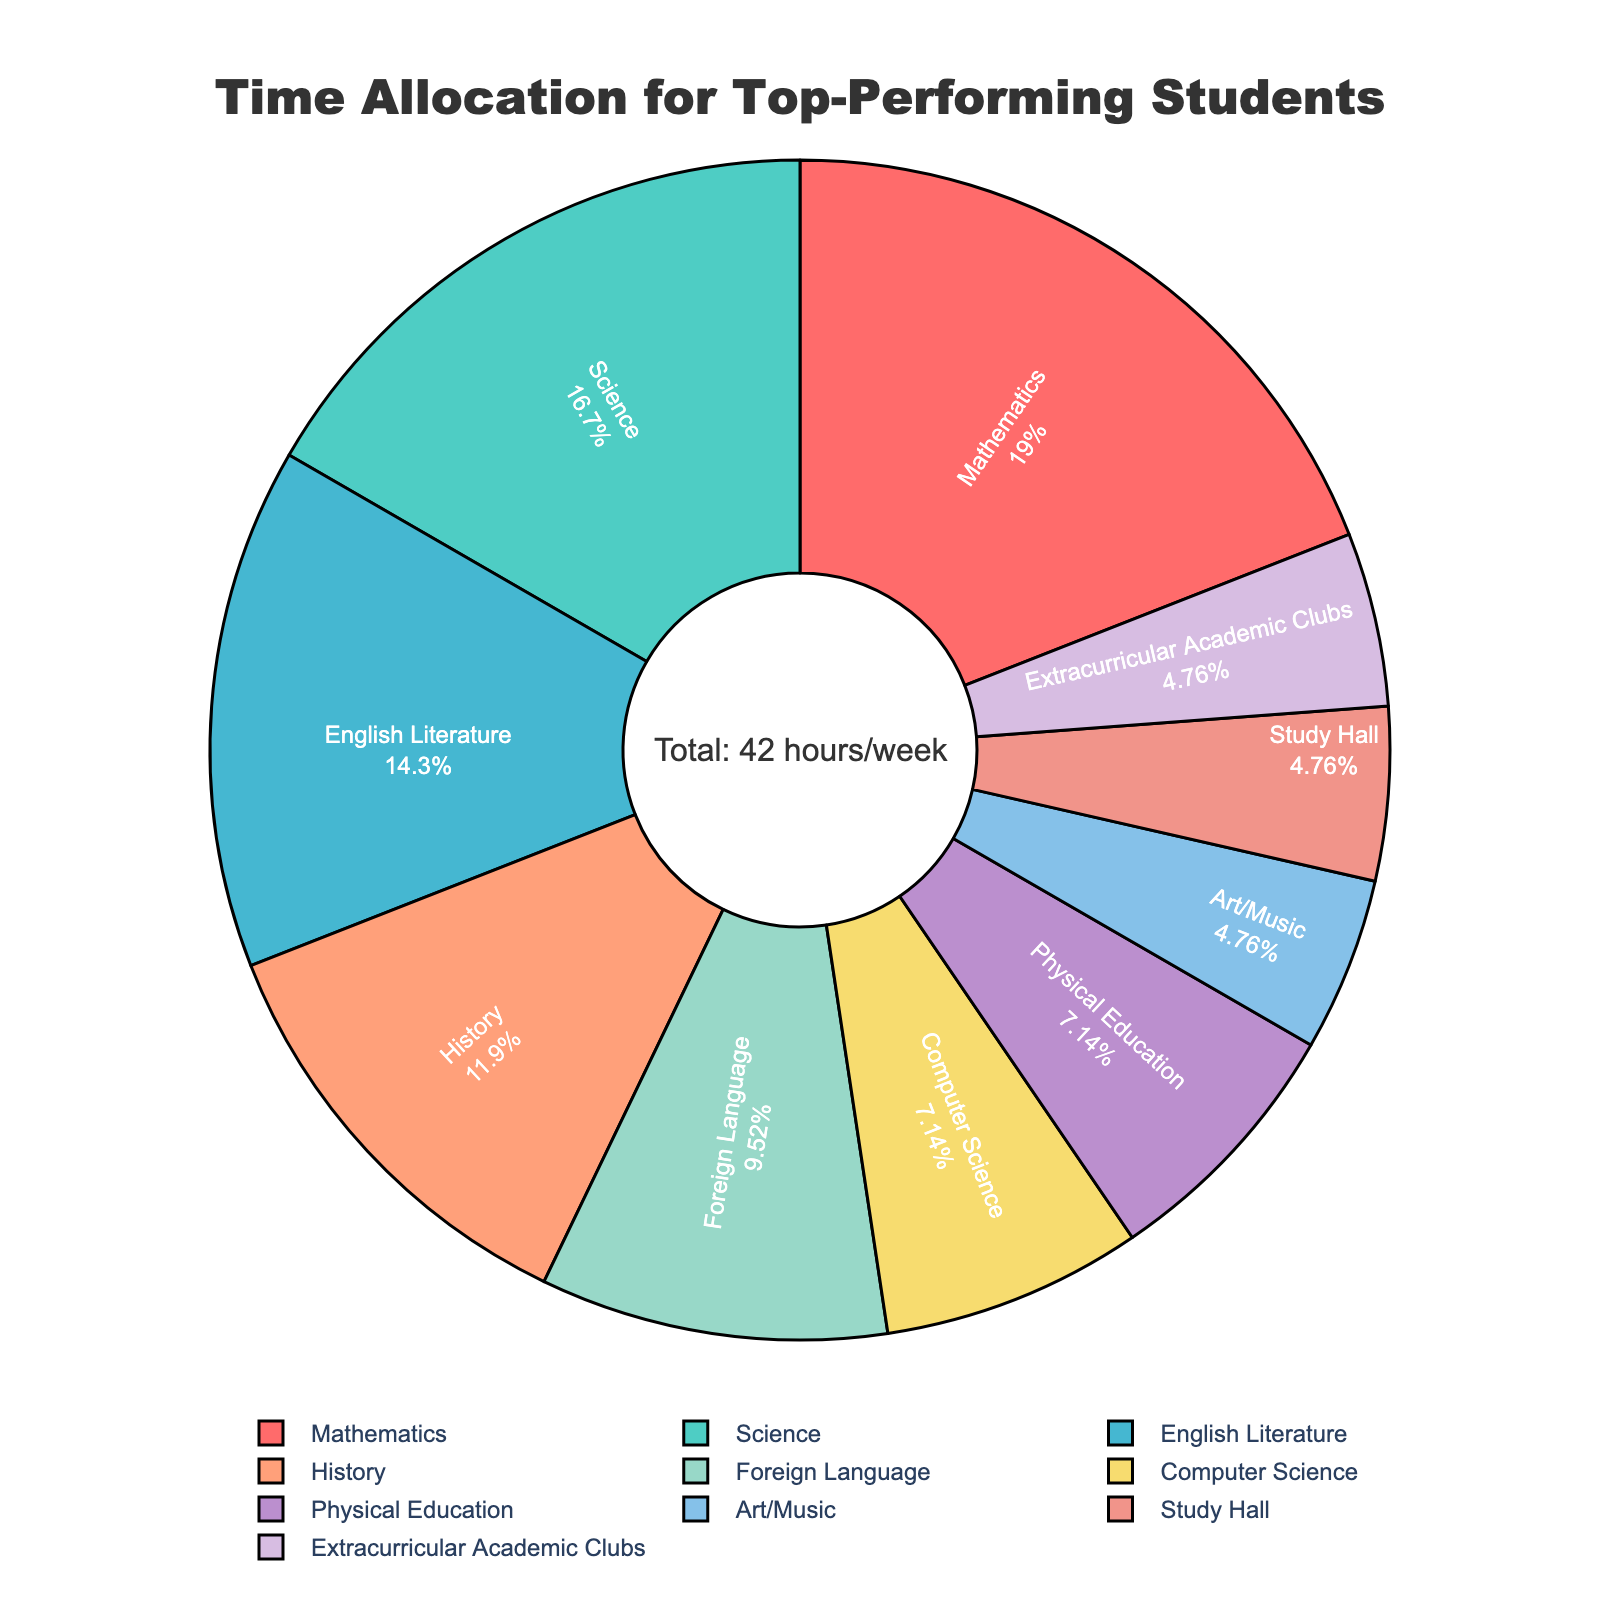What is the subject in which students spend the most time? In the figure, the largest section of the pie chart indicates the subject where students spend the most time. The label for this section will show the subject and its corresponding percentage.
Answer: Mathematics Which two subjects combined take up the same amount of time as Science? Science takes up 7 hours per week. We need to find two subjects whose hours per week sum up to 7. Checking the data, Physical Education and Computer Science each take 3 hours, and Art/Music takes 2 hours. The sum of Physical Education and Art/Music is therefore 3 + 4 = 7, which matches Science.
Answer: Physical Education and Computer Science + Art/Music What percentage of time is spent on Mathematics? The percentage is directly shown in the figure next to the "Mathematics" label.
Answer: 19% Is more time spent on English Literature or History? By comparing the sizes of the sections for "English Literature" and "History" in the pie chart, and referencing their corresponding percentages or hours, it's evident.
Answer: English Literature How does the time spent on Extracurricular Academic Clubs compare to Art/Music? Both sections of the pie chart must be compared. Checking the figure, Extracurricular Academic Clubs and Art/Music both occupy the same section size and percentage.
Answer: Equal What is the combined percentage of time spent on Foreign Language, Computer Science, and Physical Education? Firstly, recognize each subject’s percentage. Foreign Language: ~9.5%, Computer Science: ~7.1%, Physical Education: ~7.1%. Adding these gives 9.5 + 7.1 + 7.1 = 23.7%.
Answer: 23.7% How many hours per week do students spend on subjects not related to physical education or art? First, sum the hours for all subjects except Physical Education (3) and Art/Music (2): 8 + 7 + 6 + 5 + 4 + 3 + 2 = 37 hours per week.
Answer: 37 hours Which subject occupies the smallest portion of the pie chart? The smallest section of the pie chart is visually the smallest slice, and it has the smallest percentage next to its label.
Answer: Art/Music What is the total percentage of time allocated to Mathematics, Science, and English Literature? Add the individual percentages for Mathematics, Science, and English Literature: 19% + 16.7% + 14.3% = 50%.
Answer: 50% 